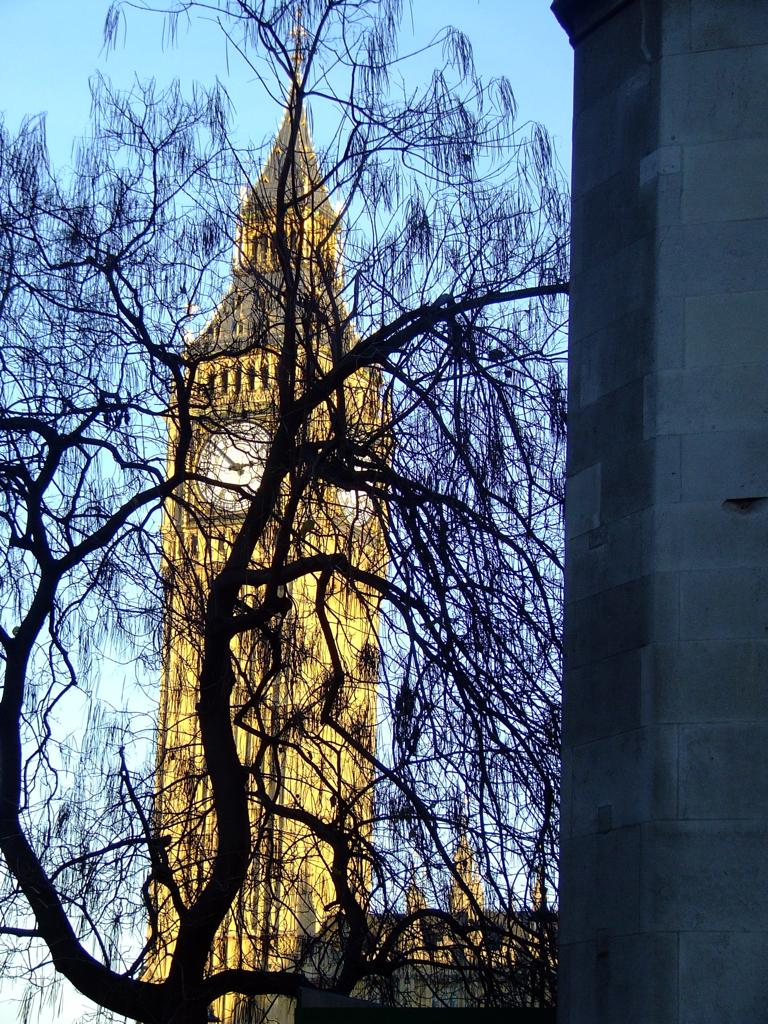What structure is located on the left side of the image? There is a pillar on the left side of the image. What type of plant can be seen in the image? There is a tree in the image. What type of building is depicted in the image? There is a clock tower in the image. What is visible in the background of the image? The sky is visible in the background of the image. How many birds are perched on the pillar in the image? There are no birds present in the image; it only features a pillar, a tree, a clock tower, and the sky. What type of wilderness can be seen in the image? There is no wilderness depicted in the image; it shows a pillar, a tree, a clock tower, and the sky. 